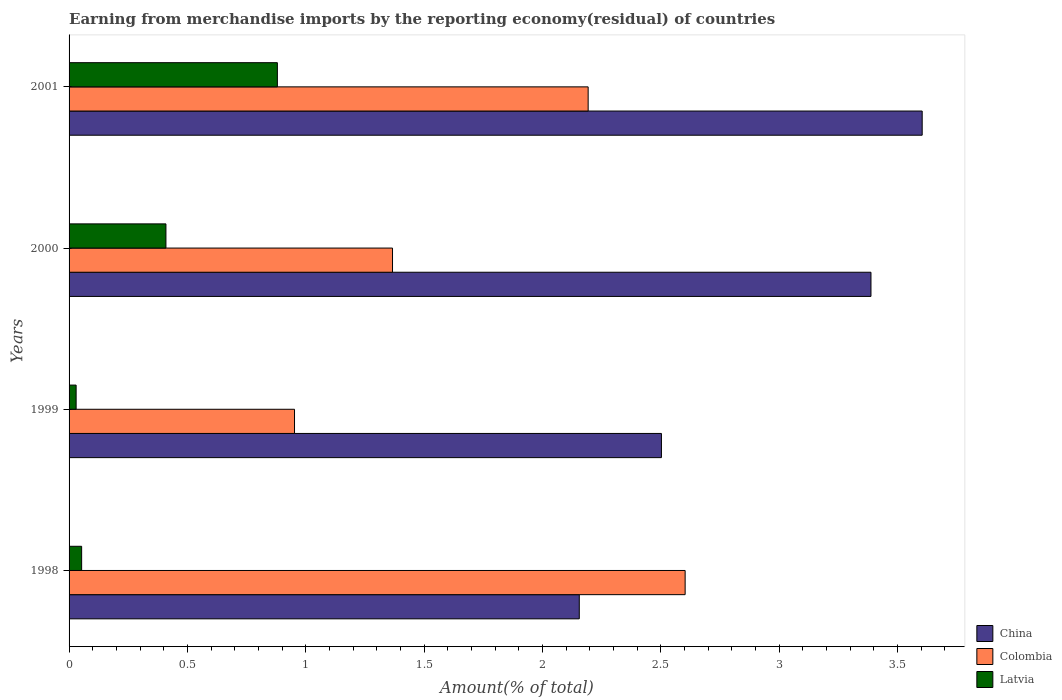How many different coloured bars are there?
Ensure brevity in your answer.  3. Are the number of bars per tick equal to the number of legend labels?
Your answer should be very brief. Yes. How many bars are there on the 1st tick from the top?
Your response must be concise. 3. What is the label of the 2nd group of bars from the top?
Provide a succinct answer. 2000. In how many cases, is the number of bars for a given year not equal to the number of legend labels?
Keep it short and to the point. 0. What is the percentage of amount earned from merchandise imports in Colombia in 1998?
Your answer should be compact. 2.6. Across all years, what is the maximum percentage of amount earned from merchandise imports in Colombia?
Your answer should be very brief. 2.6. Across all years, what is the minimum percentage of amount earned from merchandise imports in China?
Provide a succinct answer. 2.16. In which year was the percentage of amount earned from merchandise imports in China maximum?
Your answer should be very brief. 2001. What is the total percentage of amount earned from merchandise imports in Colombia in the graph?
Keep it short and to the point. 7.12. What is the difference between the percentage of amount earned from merchandise imports in Latvia in 1998 and that in 2001?
Your response must be concise. -0.83. What is the difference between the percentage of amount earned from merchandise imports in Colombia in 2000 and the percentage of amount earned from merchandise imports in Latvia in 2001?
Give a very brief answer. 0.49. What is the average percentage of amount earned from merchandise imports in Colombia per year?
Give a very brief answer. 1.78. In the year 2000, what is the difference between the percentage of amount earned from merchandise imports in Colombia and percentage of amount earned from merchandise imports in Latvia?
Make the answer very short. 0.96. In how many years, is the percentage of amount earned from merchandise imports in Latvia greater than 0.30000000000000004 %?
Provide a succinct answer. 2. What is the ratio of the percentage of amount earned from merchandise imports in Latvia in 1998 to that in 2001?
Your answer should be very brief. 0.06. Is the percentage of amount earned from merchandise imports in China in 1998 less than that in 1999?
Provide a short and direct response. Yes. What is the difference between the highest and the second highest percentage of amount earned from merchandise imports in China?
Provide a succinct answer. 0.22. What is the difference between the highest and the lowest percentage of amount earned from merchandise imports in China?
Offer a terse response. 1.45. What does the 2nd bar from the top in 1998 represents?
Make the answer very short. Colombia. What does the 1st bar from the bottom in 1999 represents?
Provide a succinct answer. China. How many bars are there?
Provide a succinct answer. 12. What is the title of the graph?
Ensure brevity in your answer.  Earning from merchandise imports by the reporting economy(residual) of countries. What is the label or title of the X-axis?
Provide a short and direct response. Amount(% of total). What is the Amount(% of total) in China in 1998?
Your answer should be very brief. 2.16. What is the Amount(% of total) of Colombia in 1998?
Make the answer very short. 2.6. What is the Amount(% of total) in Latvia in 1998?
Your answer should be very brief. 0.05. What is the Amount(% of total) of China in 1999?
Offer a terse response. 2.5. What is the Amount(% of total) of Colombia in 1999?
Offer a terse response. 0.95. What is the Amount(% of total) of Latvia in 1999?
Offer a terse response. 0.03. What is the Amount(% of total) in China in 2000?
Give a very brief answer. 3.39. What is the Amount(% of total) in Colombia in 2000?
Your answer should be compact. 1.37. What is the Amount(% of total) of Latvia in 2000?
Give a very brief answer. 0.41. What is the Amount(% of total) in China in 2001?
Make the answer very short. 3.6. What is the Amount(% of total) of Colombia in 2001?
Your answer should be compact. 2.19. What is the Amount(% of total) of Latvia in 2001?
Provide a short and direct response. 0.88. Across all years, what is the maximum Amount(% of total) of China?
Ensure brevity in your answer.  3.6. Across all years, what is the maximum Amount(% of total) of Colombia?
Your answer should be compact. 2.6. Across all years, what is the maximum Amount(% of total) of Latvia?
Provide a succinct answer. 0.88. Across all years, what is the minimum Amount(% of total) of China?
Make the answer very short. 2.16. Across all years, what is the minimum Amount(% of total) in Colombia?
Your answer should be very brief. 0.95. Across all years, what is the minimum Amount(% of total) of Latvia?
Your answer should be compact. 0.03. What is the total Amount(% of total) in China in the graph?
Provide a short and direct response. 11.65. What is the total Amount(% of total) of Colombia in the graph?
Provide a succinct answer. 7.12. What is the total Amount(% of total) of Latvia in the graph?
Offer a terse response. 1.37. What is the difference between the Amount(% of total) of China in 1998 and that in 1999?
Provide a succinct answer. -0.35. What is the difference between the Amount(% of total) of Colombia in 1998 and that in 1999?
Provide a succinct answer. 1.65. What is the difference between the Amount(% of total) in Latvia in 1998 and that in 1999?
Your answer should be compact. 0.02. What is the difference between the Amount(% of total) in China in 1998 and that in 2000?
Your response must be concise. -1.23. What is the difference between the Amount(% of total) in Colombia in 1998 and that in 2000?
Offer a terse response. 1.24. What is the difference between the Amount(% of total) in Latvia in 1998 and that in 2000?
Provide a short and direct response. -0.36. What is the difference between the Amount(% of total) in China in 1998 and that in 2001?
Ensure brevity in your answer.  -1.45. What is the difference between the Amount(% of total) of Colombia in 1998 and that in 2001?
Offer a terse response. 0.41. What is the difference between the Amount(% of total) of Latvia in 1998 and that in 2001?
Provide a short and direct response. -0.83. What is the difference between the Amount(% of total) of China in 1999 and that in 2000?
Provide a short and direct response. -0.89. What is the difference between the Amount(% of total) of Colombia in 1999 and that in 2000?
Offer a very short reply. -0.41. What is the difference between the Amount(% of total) of Latvia in 1999 and that in 2000?
Offer a terse response. -0.38. What is the difference between the Amount(% of total) in China in 1999 and that in 2001?
Provide a short and direct response. -1.1. What is the difference between the Amount(% of total) of Colombia in 1999 and that in 2001?
Provide a short and direct response. -1.24. What is the difference between the Amount(% of total) of Latvia in 1999 and that in 2001?
Your answer should be very brief. -0.85. What is the difference between the Amount(% of total) of China in 2000 and that in 2001?
Keep it short and to the point. -0.22. What is the difference between the Amount(% of total) of Colombia in 2000 and that in 2001?
Your response must be concise. -0.83. What is the difference between the Amount(% of total) in Latvia in 2000 and that in 2001?
Ensure brevity in your answer.  -0.47. What is the difference between the Amount(% of total) of China in 1998 and the Amount(% of total) of Colombia in 1999?
Your answer should be compact. 1.2. What is the difference between the Amount(% of total) in China in 1998 and the Amount(% of total) in Latvia in 1999?
Your response must be concise. 2.13. What is the difference between the Amount(% of total) of Colombia in 1998 and the Amount(% of total) of Latvia in 1999?
Your answer should be very brief. 2.57. What is the difference between the Amount(% of total) in China in 1998 and the Amount(% of total) in Colombia in 2000?
Ensure brevity in your answer.  0.79. What is the difference between the Amount(% of total) in China in 1998 and the Amount(% of total) in Latvia in 2000?
Ensure brevity in your answer.  1.75. What is the difference between the Amount(% of total) in Colombia in 1998 and the Amount(% of total) in Latvia in 2000?
Provide a succinct answer. 2.19. What is the difference between the Amount(% of total) in China in 1998 and the Amount(% of total) in Colombia in 2001?
Ensure brevity in your answer.  -0.04. What is the difference between the Amount(% of total) of China in 1998 and the Amount(% of total) of Latvia in 2001?
Give a very brief answer. 1.28. What is the difference between the Amount(% of total) of Colombia in 1998 and the Amount(% of total) of Latvia in 2001?
Your answer should be compact. 1.72. What is the difference between the Amount(% of total) of China in 1999 and the Amount(% of total) of Colombia in 2000?
Your answer should be very brief. 1.14. What is the difference between the Amount(% of total) of China in 1999 and the Amount(% of total) of Latvia in 2000?
Provide a succinct answer. 2.09. What is the difference between the Amount(% of total) in Colombia in 1999 and the Amount(% of total) in Latvia in 2000?
Your answer should be compact. 0.54. What is the difference between the Amount(% of total) in China in 1999 and the Amount(% of total) in Colombia in 2001?
Offer a terse response. 0.31. What is the difference between the Amount(% of total) in China in 1999 and the Amount(% of total) in Latvia in 2001?
Provide a succinct answer. 1.62. What is the difference between the Amount(% of total) of Colombia in 1999 and the Amount(% of total) of Latvia in 2001?
Your answer should be compact. 0.07. What is the difference between the Amount(% of total) of China in 2000 and the Amount(% of total) of Colombia in 2001?
Provide a succinct answer. 1.19. What is the difference between the Amount(% of total) of China in 2000 and the Amount(% of total) of Latvia in 2001?
Your answer should be compact. 2.51. What is the difference between the Amount(% of total) of Colombia in 2000 and the Amount(% of total) of Latvia in 2001?
Keep it short and to the point. 0.49. What is the average Amount(% of total) in China per year?
Your response must be concise. 2.91. What is the average Amount(% of total) of Colombia per year?
Offer a terse response. 1.78. What is the average Amount(% of total) in Latvia per year?
Your response must be concise. 0.34. In the year 1998, what is the difference between the Amount(% of total) in China and Amount(% of total) in Colombia?
Offer a terse response. -0.45. In the year 1998, what is the difference between the Amount(% of total) of China and Amount(% of total) of Latvia?
Provide a succinct answer. 2.1. In the year 1998, what is the difference between the Amount(% of total) of Colombia and Amount(% of total) of Latvia?
Offer a very short reply. 2.55. In the year 1999, what is the difference between the Amount(% of total) in China and Amount(% of total) in Colombia?
Give a very brief answer. 1.55. In the year 1999, what is the difference between the Amount(% of total) in China and Amount(% of total) in Latvia?
Provide a short and direct response. 2.47. In the year 1999, what is the difference between the Amount(% of total) of Colombia and Amount(% of total) of Latvia?
Provide a succinct answer. 0.92. In the year 2000, what is the difference between the Amount(% of total) of China and Amount(% of total) of Colombia?
Offer a terse response. 2.02. In the year 2000, what is the difference between the Amount(% of total) of China and Amount(% of total) of Latvia?
Provide a succinct answer. 2.98. In the year 2000, what is the difference between the Amount(% of total) in Colombia and Amount(% of total) in Latvia?
Provide a short and direct response. 0.96. In the year 2001, what is the difference between the Amount(% of total) in China and Amount(% of total) in Colombia?
Offer a very short reply. 1.41. In the year 2001, what is the difference between the Amount(% of total) in China and Amount(% of total) in Latvia?
Provide a short and direct response. 2.72. In the year 2001, what is the difference between the Amount(% of total) of Colombia and Amount(% of total) of Latvia?
Keep it short and to the point. 1.31. What is the ratio of the Amount(% of total) of China in 1998 to that in 1999?
Your response must be concise. 0.86. What is the ratio of the Amount(% of total) of Colombia in 1998 to that in 1999?
Offer a terse response. 2.73. What is the ratio of the Amount(% of total) in Latvia in 1998 to that in 1999?
Offer a very short reply. 1.78. What is the ratio of the Amount(% of total) in China in 1998 to that in 2000?
Keep it short and to the point. 0.64. What is the ratio of the Amount(% of total) of Colombia in 1998 to that in 2000?
Offer a very short reply. 1.9. What is the ratio of the Amount(% of total) in Latvia in 1998 to that in 2000?
Make the answer very short. 0.13. What is the ratio of the Amount(% of total) of China in 1998 to that in 2001?
Your answer should be compact. 0.6. What is the ratio of the Amount(% of total) of Colombia in 1998 to that in 2001?
Ensure brevity in your answer.  1.19. What is the ratio of the Amount(% of total) in Latvia in 1998 to that in 2001?
Provide a succinct answer. 0.06. What is the ratio of the Amount(% of total) of China in 1999 to that in 2000?
Your answer should be compact. 0.74. What is the ratio of the Amount(% of total) in Colombia in 1999 to that in 2000?
Keep it short and to the point. 0.7. What is the ratio of the Amount(% of total) of Latvia in 1999 to that in 2000?
Provide a succinct answer. 0.07. What is the ratio of the Amount(% of total) of China in 1999 to that in 2001?
Offer a terse response. 0.69. What is the ratio of the Amount(% of total) of Colombia in 1999 to that in 2001?
Offer a very short reply. 0.43. What is the ratio of the Amount(% of total) of Latvia in 1999 to that in 2001?
Keep it short and to the point. 0.03. What is the ratio of the Amount(% of total) in Colombia in 2000 to that in 2001?
Your answer should be very brief. 0.62. What is the ratio of the Amount(% of total) of Latvia in 2000 to that in 2001?
Keep it short and to the point. 0.47. What is the difference between the highest and the second highest Amount(% of total) of China?
Give a very brief answer. 0.22. What is the difference between the highest and the second highest Amount(% of total) of Colombia?
Provide a succinct answer. 0.41. What is the difference between the highest and the second highest Amount(% of total) of Latvia?
Provide a short and direct response. 0.47. What is the difference between the highest and the lowest Amount(% of total) of China?
Give a very brief answer. 1.45. What is the difference between the highest and the lowest Amount(% of total) of Colombia?
Offer a very short reply. 1.65. What is the difference between the highest and the lowest Amount(% of total) in Latvia?
Your answer should be compact. 0.85. 